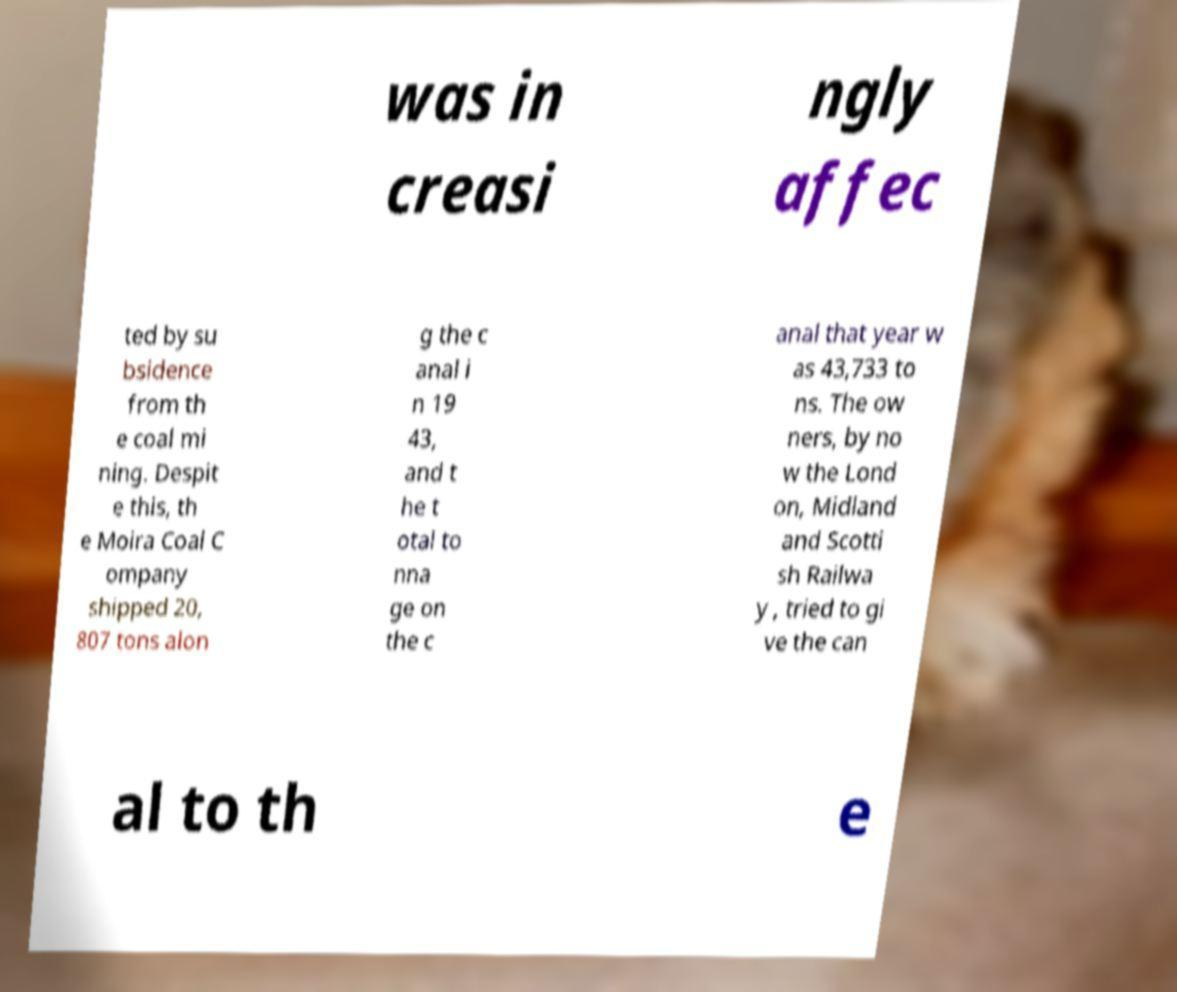Could you assist in decoding the text presented in this image and type it out clearly? was in creasi ngly affec ted by su bsidence from th e coal mi ning. Despit e this, th e Moira Coal C ompany shipped 20, 807 tons alon g the c anal i n 19 43, and t he t otal to nna ge on the c anal that year w as 43,733 to ns. The ow ners, by no w the Lond on, Midland and Scotti sh Railwa y , tried to gi ve the can al to th e 